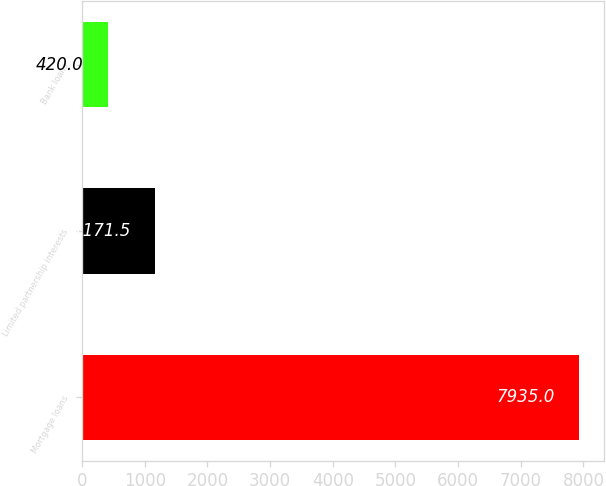Convert chart to OTSL. <chart><loc_0><loc_0><loc_500><loc_500><bar_chart><fcel>Mortgage loans<fcel>Limited partnership interests<fcel>Bank loans<nl><fcel>7935<fcel>1171.5<fcel>420<nl></chart> 